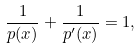<formula> <loc_0><loc_0><loc_500><loc_500>\frac { 1 } { p ( x ) } + \frac { 1 } { p ^ { \prime } ( x ) } = 1 ,</formula> 